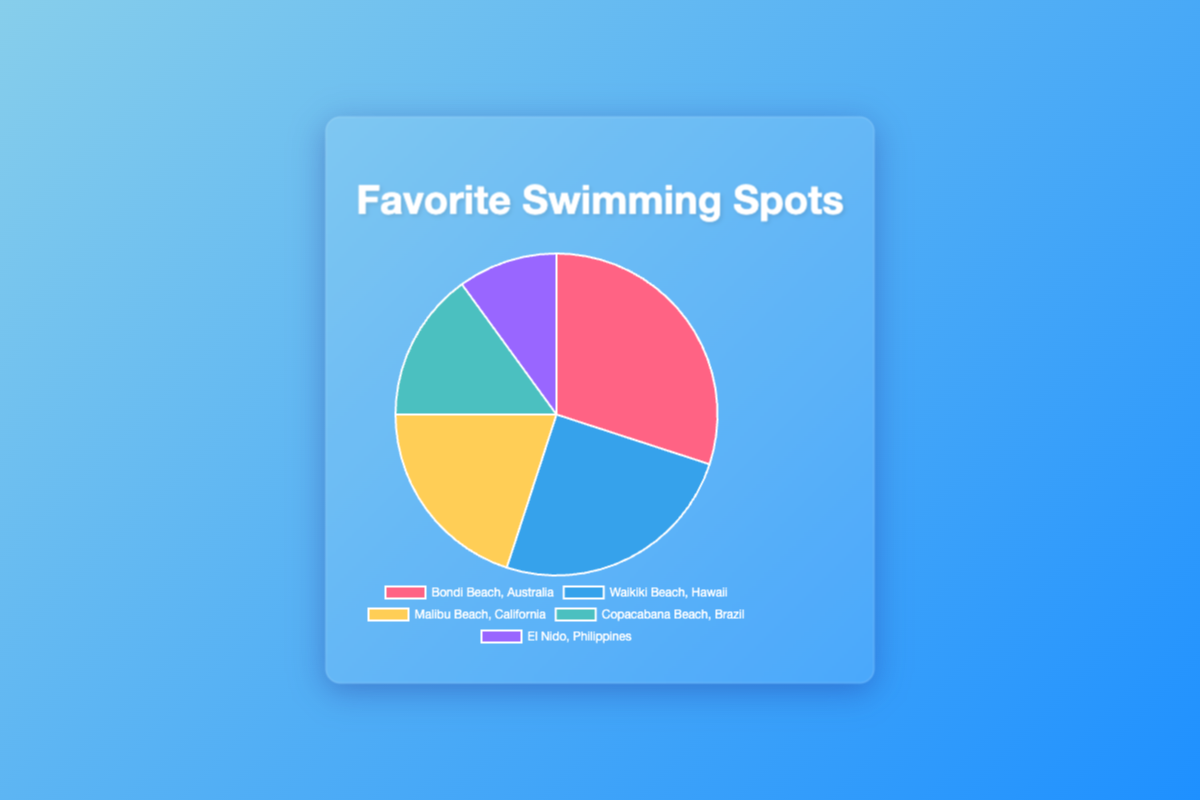What is the most frequently visited swimming spot? By inspecting the pie chart, you can see that Bondi Beach, Australia has the largest segment. This indicates that Bondi Beach is the most frequently visited swimming spot with 30 visits.
Answer: Bondi Beach, Australia How many more visits does Bondi Beach have compared to El Nido, Philippines? Bondi Beach has 30 visits, while El Nido has 10 visits. To find the difference, subtract 10 from 30: 30 - 10 = 20.
Answer: 20 Which swimming spot has the fewest visits? Observing the pie chart, the smallest segment corresponds to El Nido, Philippines. This indicates that El Nido has the fewest visits with 10.
Answer: El Nido, Philippines Are the visits to Waikiki Beach and Malibu Beach together more than the visits to Bondi Beach? Waikiki Beach has 25 visits, and Malibu Beach has 20 visits. Summing them gives: 25 + 20 = 45. Bondi Beach has 30 visits. Since 45 is greater than 30, the visits to Waikiki Beach and Malibu Beach together are more.
Answer: Yes What is the total number of visits to all swimming spots? Summing the visits for all spots: 30 (Bondi) + 25 (Waikiki) + 20 (Malibu) + 15 (Copacabana) + 10 (El Nido) = 100.
Answer: 100 Which swimming spot has the second highest number of visits? The second largest segment corresponds to Waikiki Beach, Hawaii, which has 25 visits, following Bondi Beach which has 30 visits.
Answer: Waikiki Beach, Hawaii What percentage of the total visits is to Malibu Beach, California? Malibu Beach has 20 visits out of a total of 100. To find the percentage: (20 / 100) * 100 = 20%.
Answer: 20% How many more visits does Waikiki Beach have compared to Copacabana Beach? Waikiki Beach has 25 visits, whereas Copacabana Beach has 15 visits. Subtracting 15 from 25 gives: 25 - 15 = 10.
Answer: 10 Which swimming spot's segment in the pie chart is colored blue? Observing the colors in the pie chart, the segment colored blue corresponds to Waikiki Beach, Hawaii.
Answer: Waikiki Beach, Hawaii 